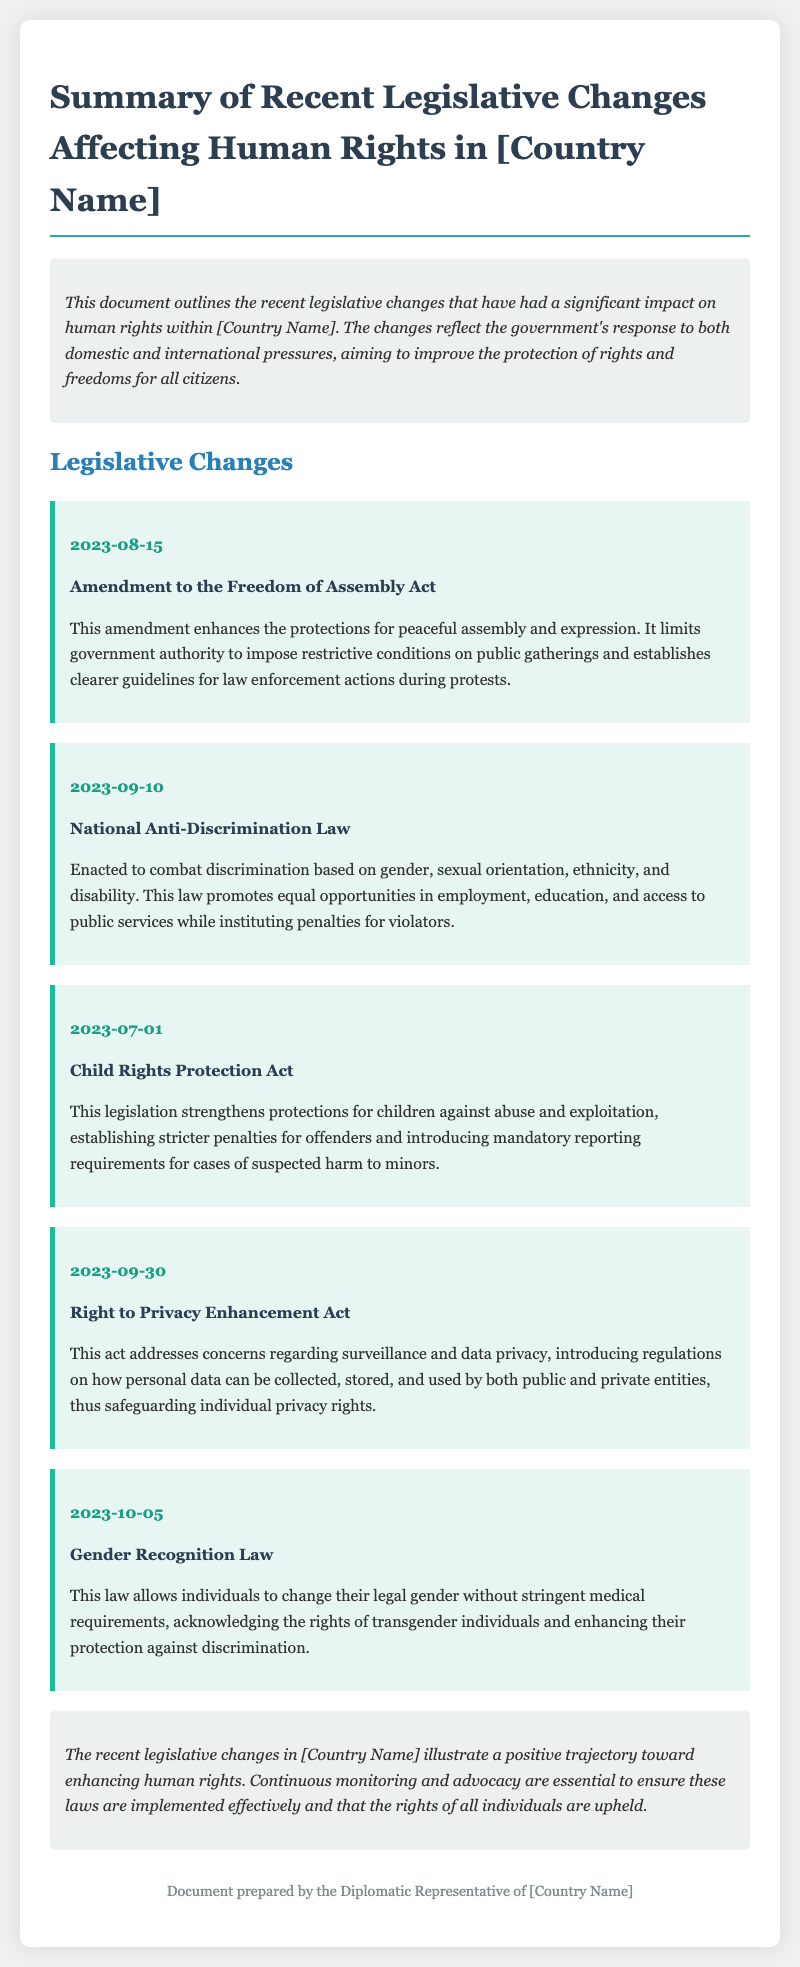What is the date of the amendment to the Freedom of Assembly Act? The document states that the amendment was enacted on August 15, 2023.
Answer: 2023-08-15 What is the title of the law enacted on September 10, 2023? According to the document, the law enacted on September 10, 2023, is the National Anti-Discrimination Law.
Answer: National Anti-Discrimination Law What are the protections strengthened by the Child Rights Protection Act? The Child Rights Protection Act strengthens protections against abuse and exploitation for children.
Answer: Abuse and exploitation What does the Right to Privacy Enhancement Act regulate? The act regulates how personal data can be collected, stored, and used, addressing concerns about privacy.
Answer: Personal data collection, storage, and use What is a key feature of the Gender Recognition Law? The Gender Recognition Law allows individuals to change their legal gender without stringent medical requirements.
Answer: Change legal gender without stringent medical requirements What is the overall assessment of recent legislative changes in [Country Name]? The conclusion states that the recent changes illustrate a positive trajectory toward enhancing human rights.
Answer: Positive trajectory How many legislative changes are listed in the document? The document lists five recent legislative changes.
Answer: Five What is the role of continuous monitoring according to the conclusion? The conclusion emphasizes that continuous monitoring is essential to ensure effective implementation of the laws.
Answer: Ensure effective implementation What is the purpose of the National Anti-Discrimination Law? The purpose of the National Anti-Discrimination Law is to combat discrimination based on various factors such as gender and ethnicity.
Answer: Combat discrimination What does the introduction highlight regarding recent legislative changes? The introduction highlights that the changes reflect the government's response to domestic and international pressures.
Answer: Response to domestic and international pressures 